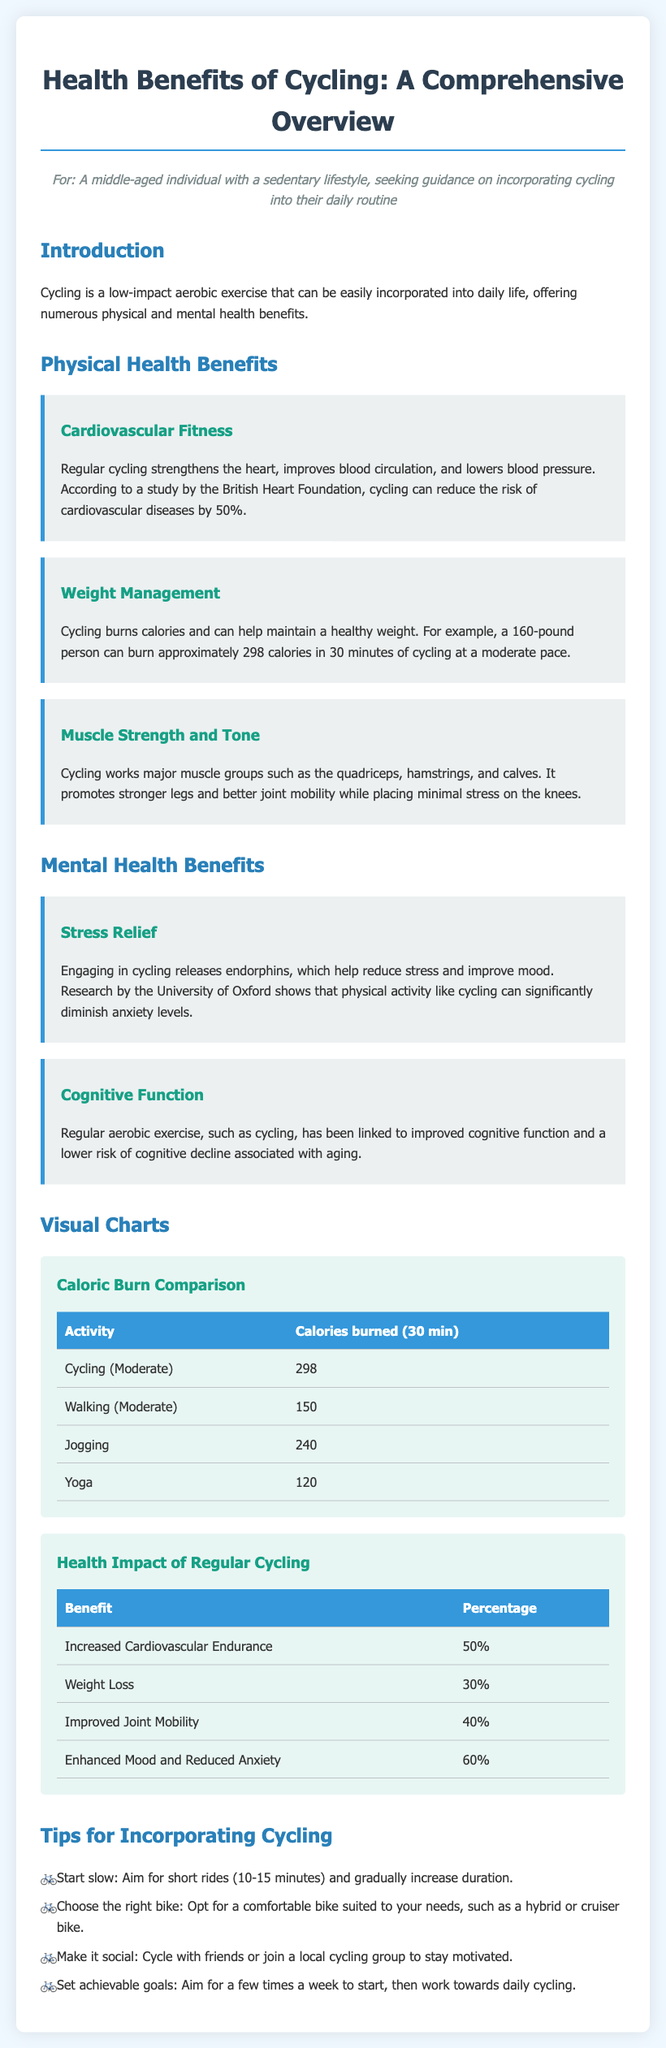What is one health benefit of cycling? The document states that cycling can reduce the risk of cardiovascular diseases by 50%.
Answer: 50% How many calories does a 160-pound person burn in 30 minutes of moderate cycling? According to the document, a 160-pound person burns approximately 298 calories in 30 minutes of cycling at a moderate pace.
Answer: 298 calories What percentage benefit does regular cycling provide for enhanced mood and reduced anxiety? The percentage of enhanced mood and reduced anxiety benefit from regular cycling is given in the health impact table.
Answer: 60% Which major muscle groups are worked during cycling? The document mentions that cycling works major muscle groups such as the quadriceps, hamstrings, and calves.
Answer: Quadriceps, hamstrings, calves What is a recommended starting duration for cycling rides? The document suggests starting with short rides and explicitly mentions 10-15 minutes as a starting aim.
Answer: 10-15 minutes What is one tip provided for incorporating cycling into your routine? One tip from the document for incorporating cycling is to set achievable goals for frequency.
Answer: Set achievable goals Which activity burns more calories in 30 minutes than moderate cycling? The document includes a comparison chart, and jogging burns 240 calories, which is less than cycling but more than yoga's 120 calories.
Answer: Jogging What is the main focus of the document? The document provides a comprehensive overview of the health benefits of cycling.
Answer: Health benefits of cycling 